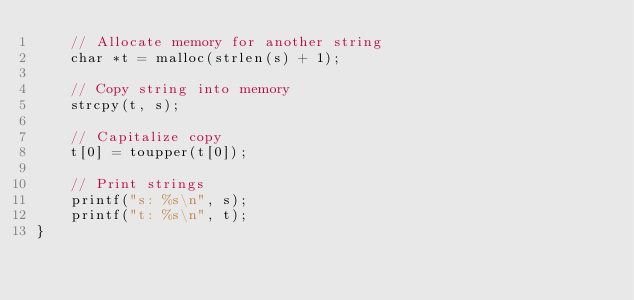Convert code to text. <code><loc_0><loc_0><loc_500><loc_500><_C_>    // Allocate memory for another string
    char *t = malloc(strlen(s) + 1);

    // Copy string into memory
    strcpy(t, s);

    // Capitalize copy
    t[0] = toupper(t[0]);

    // Print strings
    printf("s: %s\n", s);
    printf("t: %s\n", t);
}
</code> 